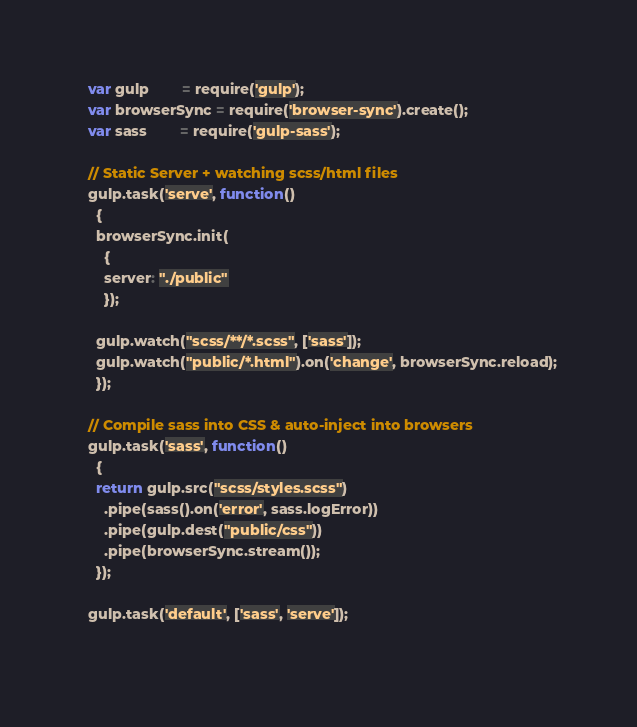<code> <loc_0><loc_0><loc_500><loc_500><_JavaScript_>  var gulp        = require('gulp');
  var browserSync = require('browser-sync').create();
  var sass        = require('gulp-sass');

  // Static Server + watching scss/html files
  gulp.task('serve', function()
    {
    browserSync.init(
      {
      server: "./public"
      });
  
    gulp.watch("scss/**/*.scss", ['sass']);
    gulp.watch("public/*.html").on('change', browserSync.reload);
    });

  // Compile sass into CSS & auto-inject into browsers
  gulp.task('sass', function()
    {
    return gulp.src("scss/styles.scss")
      .pipe(sass().on('error', sass.logError))
      .pipe(gulp.dest("public/css"))
      .pipe(browserSync.stream());
    });
  
  gulp.task('default', ['sass', 'serve']);
  </code> 